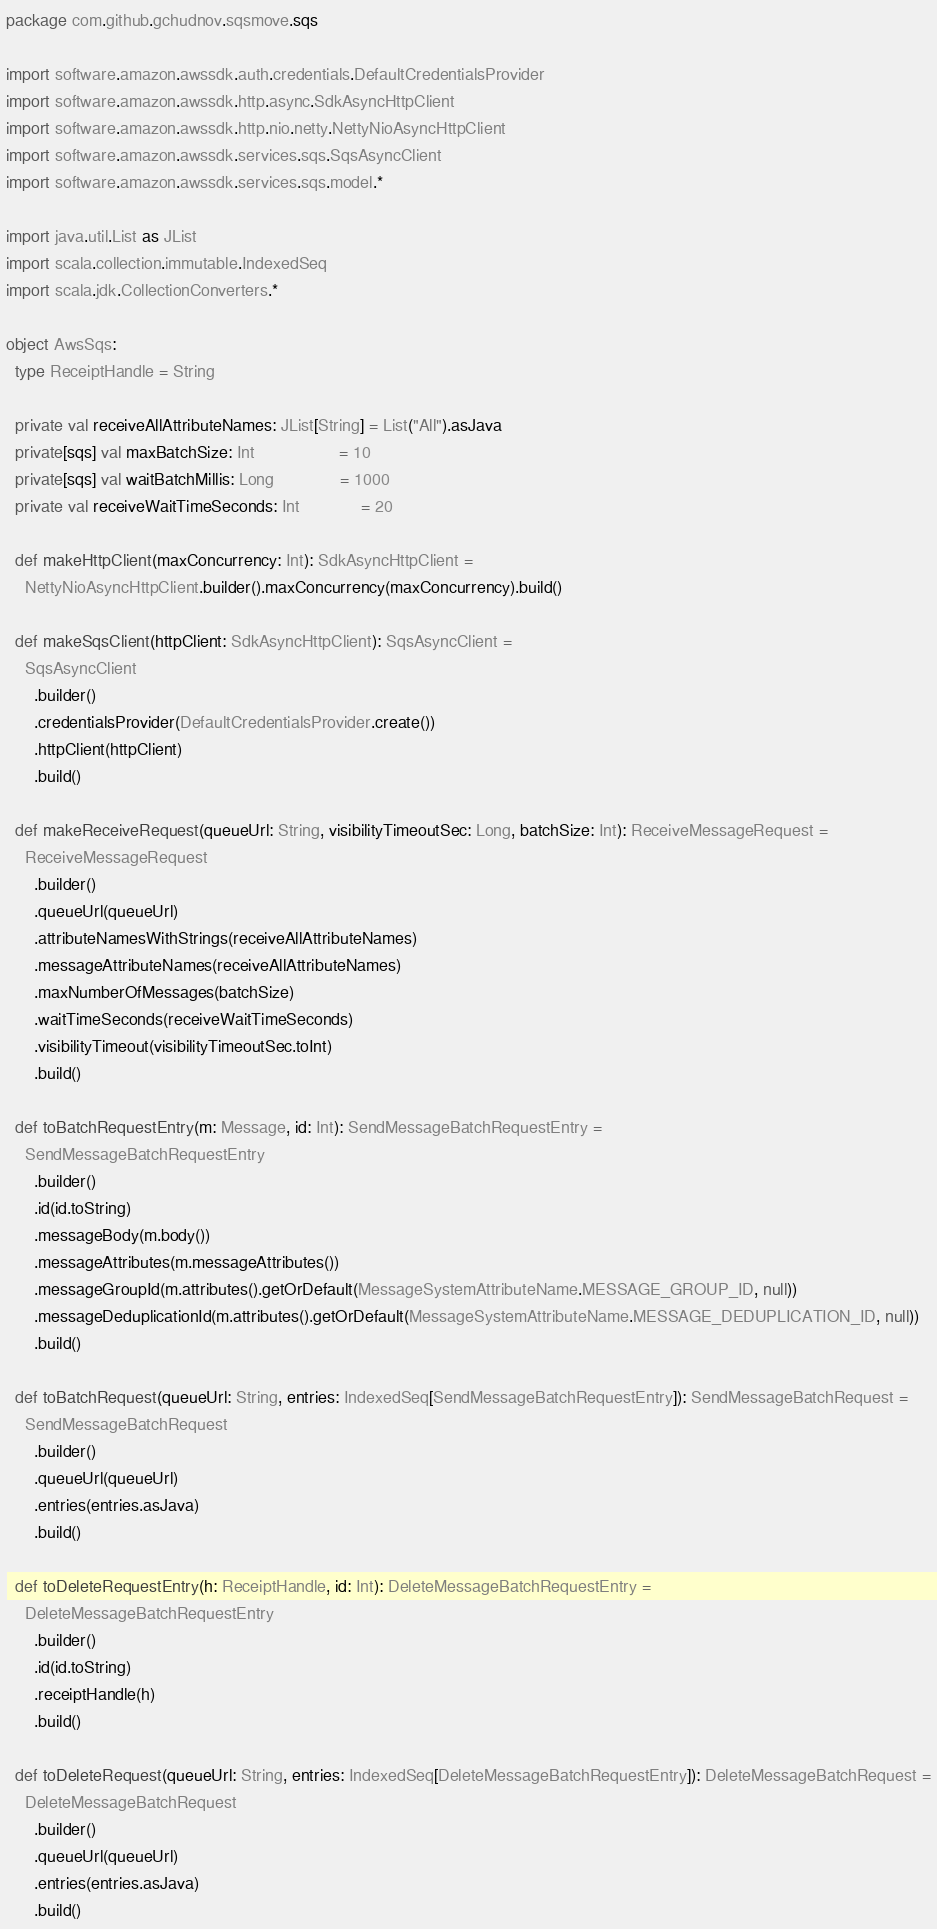<code> <loc_0><loc_0><loc_500><loc_500><_Scala_>package com.github.gchudnov.sqsmove.sqs

import software.amazon.awssdk.auth.credentials.DefaultCredentialsProvider
import software.amazon.awssdk.http.async.SdkAsyncHttpClient
import software.amazon.awssdk.http.nio.netty.NettyNioAsyncHttpClient
import software.amazon.awssdk.services.sqs.SqsAsyncClient
import software.amazon.awssdk.services.sqs.model.*

import java.util.List as JList
import scala.collection.immutable.IndexedSeq
import scala.jdk.CollectionConverters.*

object AwsSqs:
  type ReceiptHandle = String

  private val receiveAllAttributeNames: JList[String] = List("All").asJava
  private[sqs] val maxBatchSize: Int                  = 10
  private[sqs] val waitBatchMillis: Long              = 1000
  private val receiveWaitTimeSeconds: Int             = 20

  def makeHttpClient(maxConcurrency: Int): SdkAsyncHttpClient =
    NettyNioAsyncHttpClient.builder().maxConcurrency(maxConcurrency).build()

  def makeSqsClient(httpClient: SdkAsyncHttpClient): SqsAsyncClient =
    SqsAsyncClient
      .builder()
      .credentialsProvider(DefaultCredentialsProvider.create())
      .httpClient(httpClient)
      .build()

  def makeReceiveRequest(queueUrl: String, visibilityTimeoutSec: Long, batchSize: Int): ReceiveMessageRequest =
    ReceiveMessageRequest
      .builder()
      .queueUrl(queueUrl)
      .attributeNamesWithStrings(receiveAllAttributeNames)
      .messageAttributeNames(receiveAllAttributeNames)
      .maxNumberOfMessages(batchSize)
      .waitTimeSeconds(receiveWaitTimeSeconds)
      .visibilityTimeout(visibilityTimeoutSec.toInt)
      .build()

  def toBatchRequestEntry(m: Message, id: Int): SendMessageBatchRequestEntry =
    SendMessageBatchRequestEntry
      .builder()
      .id(id.toString)
      .messageBody(m.body())
      .messageAttributes(m.messageAttributes())
      .messageGroupId(m.attributes().getOrDefault(MessageSystemAttributeName.MESSAGE_GROUP_ID, null))
      .messageDeduplicationId(m.attributes().getOrDefault(MessageSystemAttributeName.MESSAGE_DEDUPLICATION_ID, null))
      .build()

  def toBatchRequest(queueUrl: String, entries: IndexedSeq[SendMessageBatchRequestEntry]): SendMessageBatchRequest =
    SendMessageBatchRequest
      .builder()
      .queueUrl(queueUrl)
      .entries(entries.asJava)
      .build()

  def toDeleteRequestEntry(h: ReceiptHandle, id: Int): DeleteMessageBatchRequestEntry =
    DeleteMessageBatchRequestEntry
      .builder()
      .id(id.toString)
      .receiptHandle(h)
      .build()

  def toDeleteRequest(queueUrl: String, entries: IndexedSeq[DeleteMessageBatchRequestEntry]): DeleteMessageBatchRequest =
    DeleteMessageBatchRequest
      .builder()
      .queueUrl(queueUrl)
      .entries(entries.asJava)
      .build()
</code> 